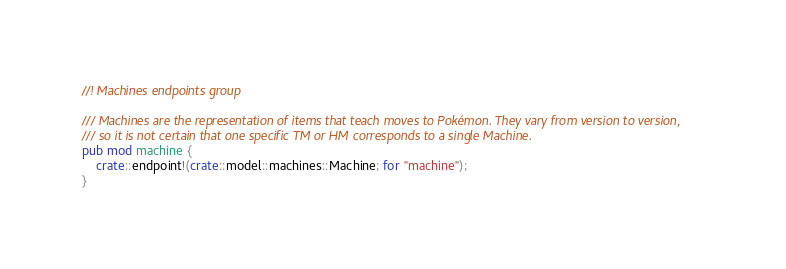Convert code to text. <code><loc_0><loc_0><loc_500><loc_500><_Rust_>//! Machines endpoints group

/// Machines are the representation of items that teach moves to Pokémon. They vary from version to version,
/// so it is not certain that one specific TM or HM corresponds to a single Machine.
pub mod machine {
    crate::endpoint!(crate::model::machines::Machine; for "machine");
}
</code> 